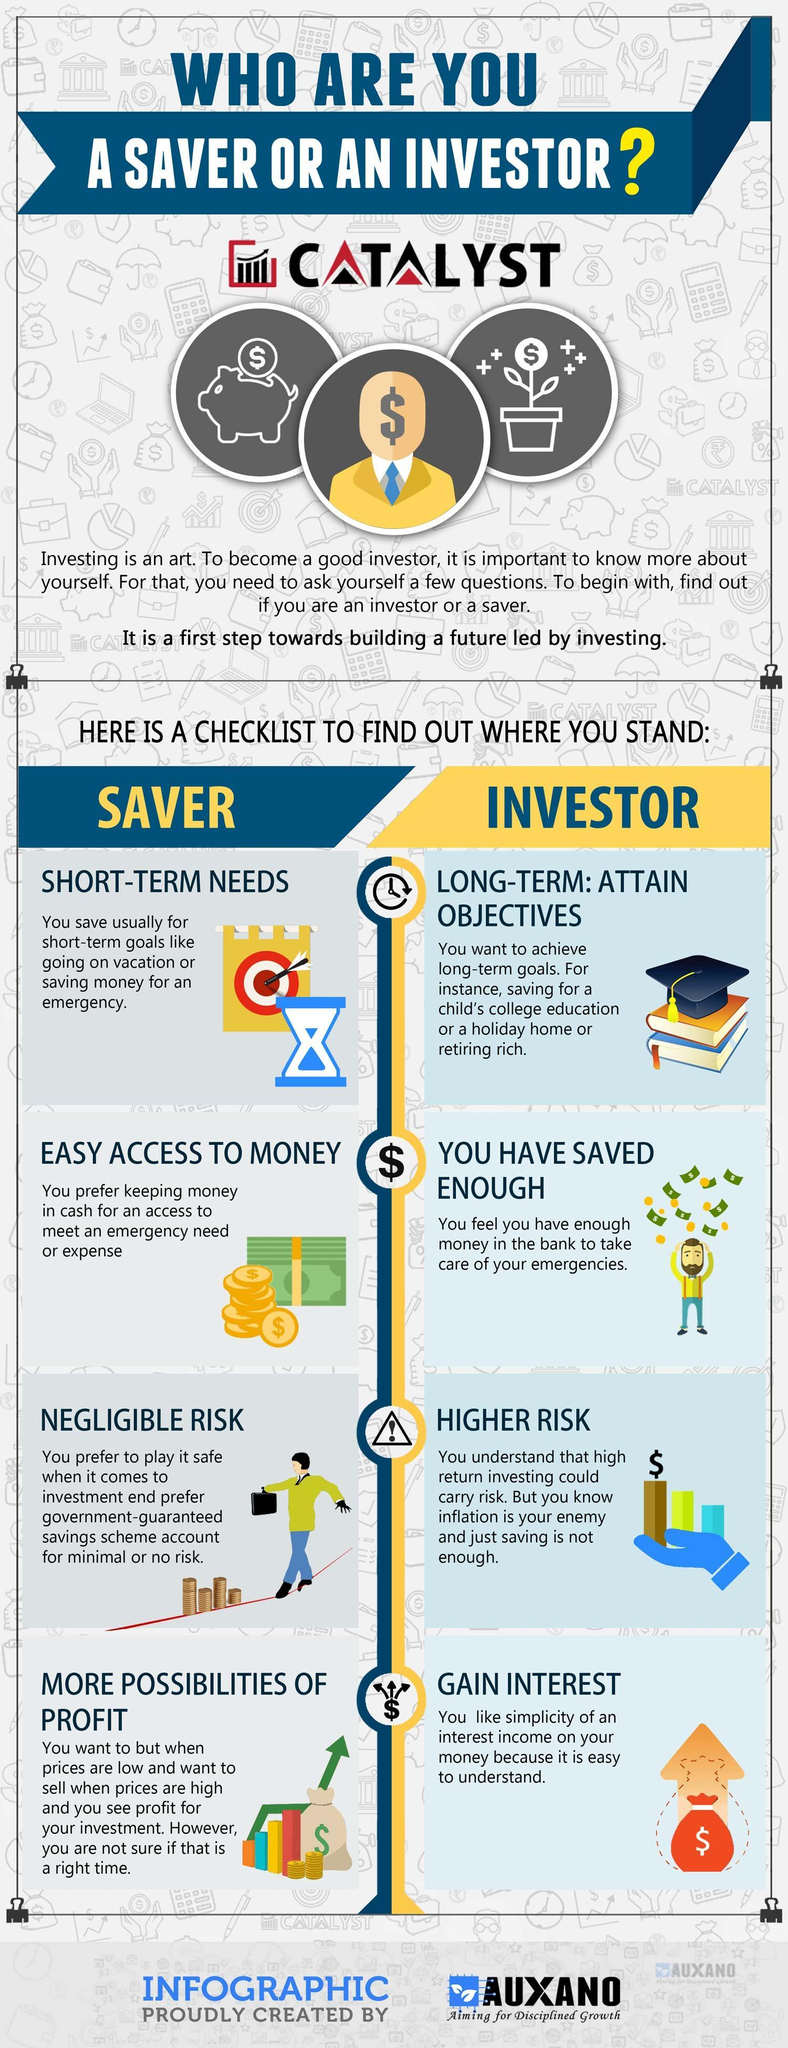Who is at a higher risk?
Answer the question with a short phrase. INVESTOR 